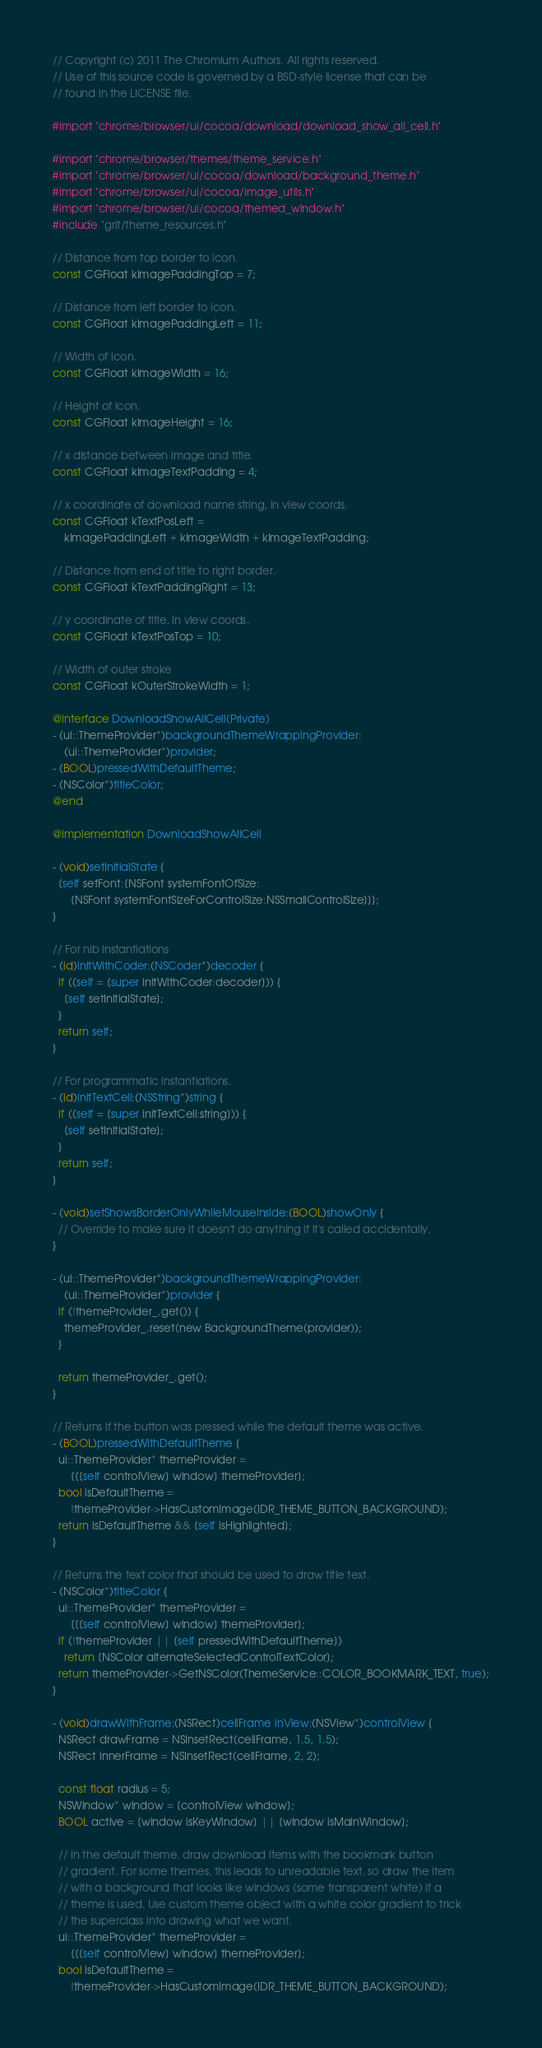<code> <loc_0><loc_0><loc_500><loc_500><_ObjectiveC_>// Copyright (c) 2011 The Chromium Authors. All rights reserved.
// Use of this source code is governed by a BSD-style license that can be
// found in the LICENSE file.

#import "chrome/browser/ui/cocoa/download/download_show_all_cell.h"

#import "chrome/browser/themes/theme_service.h"
#import "chrome/browser/ui/cocoa/download/background_theme.h"
#import "chrome/browser/ui/cocoa/image_utils.h"
#import "chrome/browser/ui/cocoa/themed_window.h"
#include "grit/theme_resources.h"

// Distance from top border to icon.
const CGFloat kImagePaddingTop = 7;

// Distance from left border to icon.
const CGFloat kImagePaddingLeft = 11;

// Width of icon.
const CGFloat kImageWidth = 16;

// Height of icon.
const CGFloat kImageHeight = 16;

// x distance between image and title.
const CGFloat kImageTextPadding = 4;

// x coordinate of download name string, in view coords.
const CGFloat kTextPosLeft =
    kImagePaddingLeft + kImageWidth + kImageTextPadding;

// Distance from end of title to right border.
const CGFloat kTextPaddingRight = 13;

// y coordinate of title, in view coords.
const CGFloat kTextPosTop = 10;

// Width of outer stroke
const CGFloat kOuterStrokeWidth = 1;

@interface DownloadShowAllCell(Private)
- (ui::ThemeProvider*)backgroundThemeWrappingProvider:
    (ui::ThemeProvider*)provider;
- (BOOL)pressedWithDefaultTheme;
- (NSColor*)titleColor;
@end

@implementation DownloadShowAllCell

- (void)setInitialState {
  [self setFont:[NSFont systemFontOfSize:
      [NSFont systemFontSizeForControlSize:NSSmallControlSize]]];
}

// For nib instantiations
- (id)initWithCoder:(NSCoder*)decoder {
  if ((self = [super initWithCoder:decoder])) {
    [self setInitialState];
  }
  return self;
}

// For programmatic instantiations.
- (id)initTextCell:(NSString*)string {
  if ((self = [super initTextCell:string])) {
    [self setInitialState];
  }
  return self;
}

- (void)setShowsBorderOnlyWhileMouseInside:(BOOL)showOnly {
  // Override to make sure it doesn't do anything if it's called accidentally.
}

- (ui::ThemeProvider*)backgroundThemeWrappingProvider:
    (ui::ThemeProvider*)provider {
  if (!themeProvider_.get()) {
    themeProvider_.reset(new BackgroundTheme(provider));
  }

  return themeProvider_.get();
}

// Returns if the button was pressed while the default theme was active.
- (BOOL)pressedWithDefaultTheme {
  ui::ThemeProvider* themeProvider =
      [[[self controlView] window] themeProvider];
  bool isDefaultTheme =
      !themeProvider->HasCustomImage(IDR_THEME_BUTTON_BACKGROUND);
  return isDefaultTheme && [self isHighlighted];
}

// Returns the text color that should be used to draw title text.
- (NSColor*)titleColor {
  ui::ThemeProvider* themeProvider =
      [[[self controlView] window] themeProvider];
  if (!themeProvider || [self pressedWithDefaultTheme])
    return [NSColor alternateSelectedControlTextColor];
  return themeProvider->GetNSColor(ThemeService::COLOR_BOOKMARK_TEXT, true);
}

- (void)drawWithFrame:(NSRect)cellFrame inView:(NSView*)controlView {
  NSRect drawFrame = NSInsetRect(cellFrame, 1.5, 1.5);
  NSRect innerFrame = NSInsetRect(cellFrame, 2, 2);

  const float radius = 5;
  NSWindow* window = [controlView window];
  BOOL active = [window isKeyWindow] || [window isMainWindow];

  // In the default theme, draw download items with the bookmark button
  // gradient. For some themes, this leads to unreadable text, so draw the item
  // with a background that looks like windows (some transparent white) if a
  // theme is used. Use custom theme object with a white color gradient to trick
  // the superclass into drawing what we want.
  ui::ThemeProvider* themeProvider =
      [[[self controlView] window] themeProvider];
  bool isDefaultTheme =
      !themeProvider->HasCustomImage(IDR_THEME_BUTTON_BACKGROUND);
</code> 